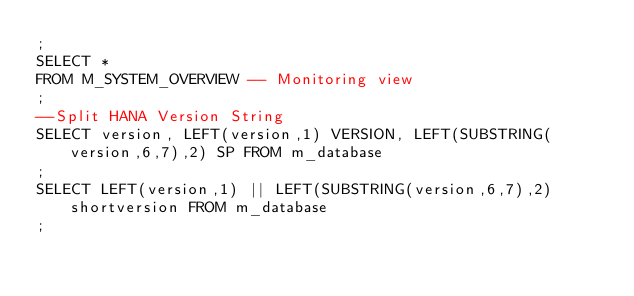Convert code to text. <code><loc_0><loc_0><loc_500><loc_500><_SQL_>;
SELECT *
FROM M_SYSTEM_OVERVIEW -- Monitoring view
;
--Split HANA Version String
SELECT version, LEFT(version,1) VERSION, LEFT(SUBSTRING(version,6,7),2) SP FROM m_database
;
SELECT LEFT(version,1) || LEFT(SUBSTRING(version,6,7),2) shortversion FROM m_database
;</code> 